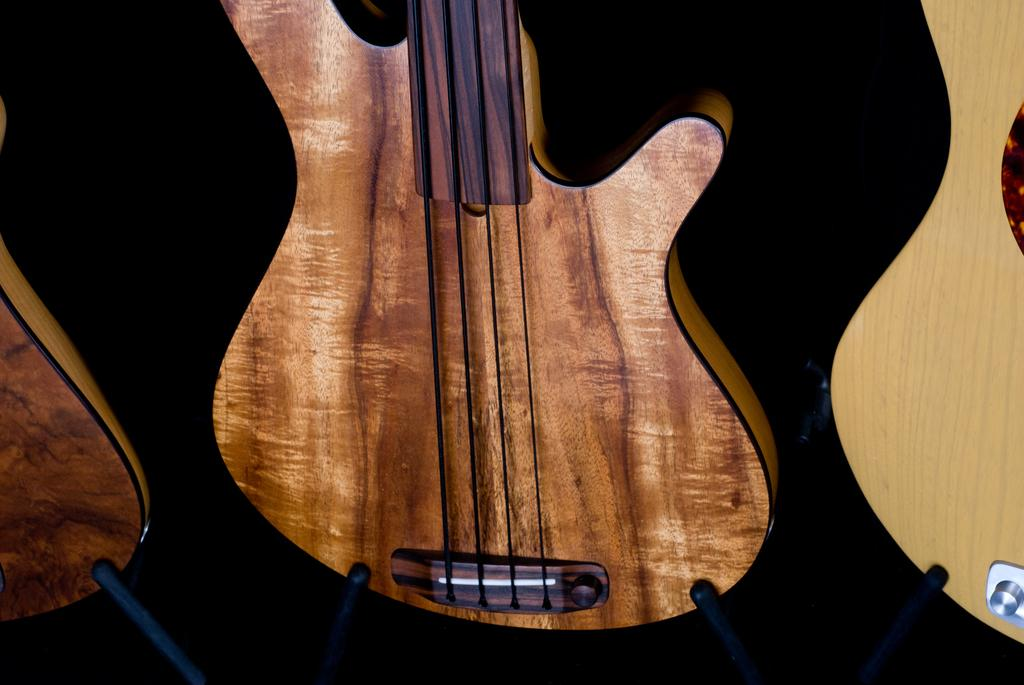What musical instrument is present in the image? There is a guitar in the image. Where is the guitar located? The guitar is on a table. How many spiders are crawling on the guitar in the image? There are no spiders present in the image; it only features a guitar on a table. 